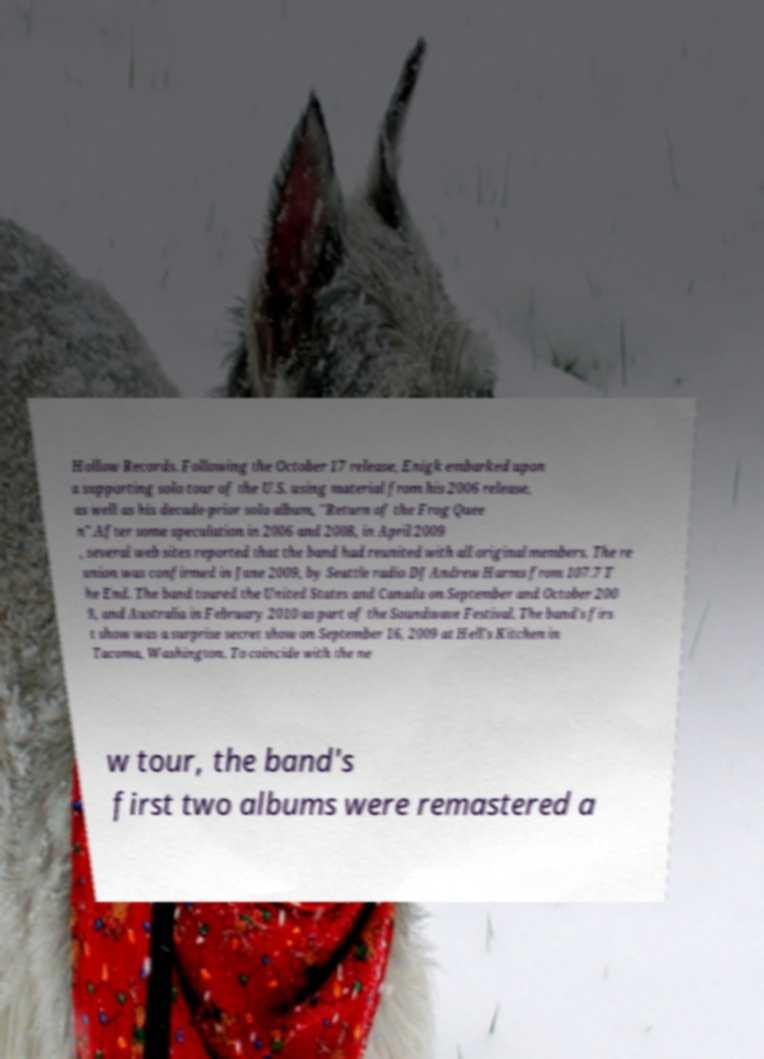Can you read and provide the text displayed in the image?This photo seems to have some interesting text. Can you extract and type it out for me? Hollow Records. Following the October 17 release, Enigk embarked upon a supporting solo tour of the U.S. using material from his 2006 release, as well as his decade-prior solo album, "Return of the Frog Quee n".After some speculation in 2006 and 2008, in April 2009 , several web sites reported that the band had reunited with all original members. The re union was confirmed in June 2009, by Seattle radio DJ Andrew Harms from 107.7 T he End. The band toured the United States and Canada on September and October 200 9, and Australia in February 2010 as part of the Soundwave Festival. The band's firs t show was a surprise secret show on September 16, 2009 at Hell's Kitchen in Tacoma, Washington. To coincide with the ne w tour, the band's first two albums were remastered a 